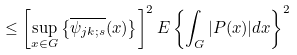Convert formula to latex. <formula><loc_0><loc_0><loc_500><loc_500>\leq \left [ \sup _ { x \in G } \left \{ \overline { \psi _ { j k ; s } } ( x ) \right \} \right ] ^ { 2 } E \left \{ \int _ { G } | P ( x ) | d x \right \} ^ { 2 }</formula> 